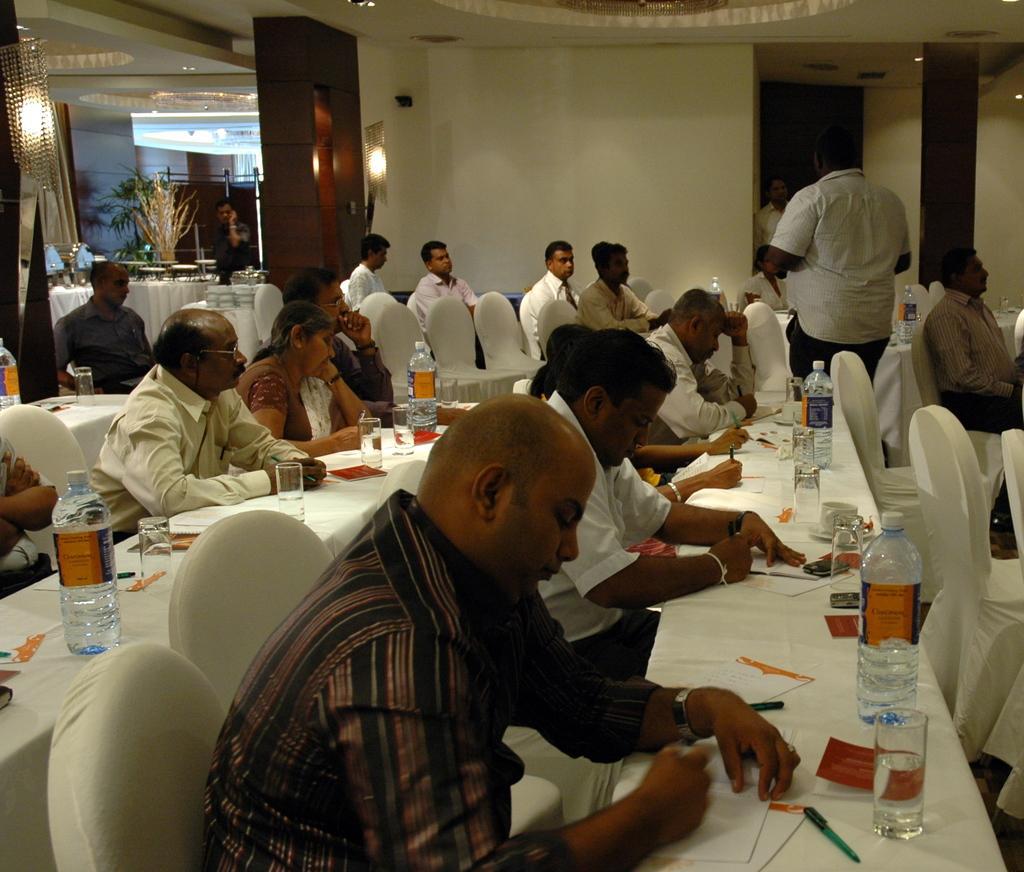Can you describe this image briefly? As we can see in the image there is a white color wall, lights, plants, group of people, chairs and tables. On tables there are papers, pens, glasses, bottles and white color clothes. 